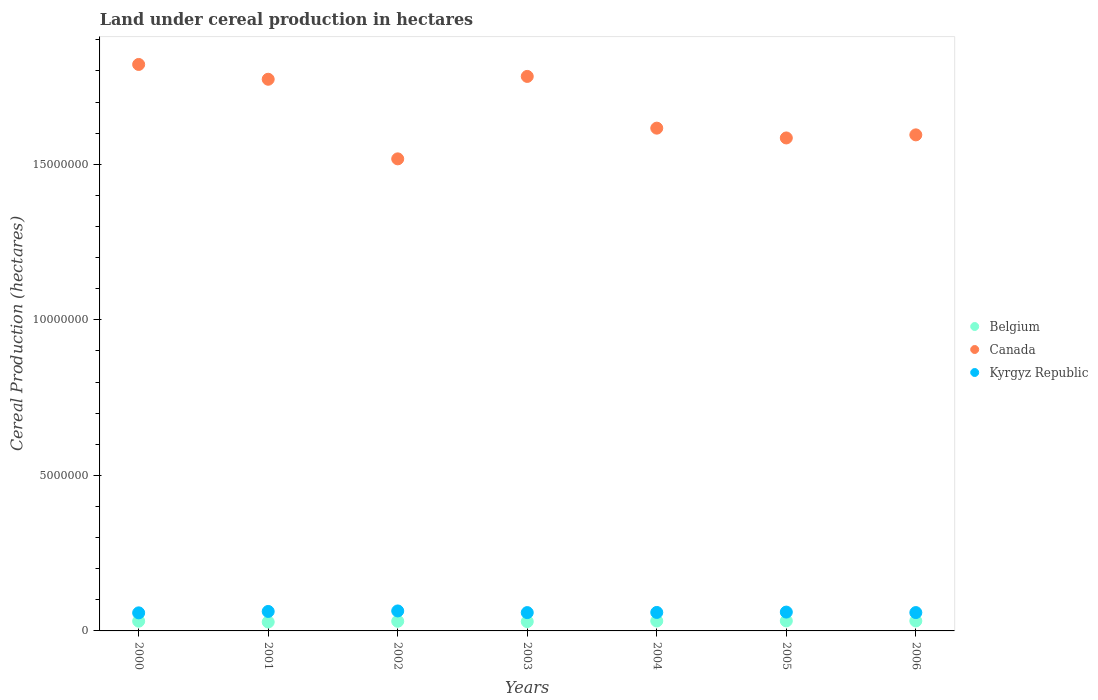Is the number of dotlines equal to the number of legend labels?
Your response must be concise. Yes. What is the land under cereal production in Kyrgyz Republic in 2002?
Offer a terse response. 6.42e+05. Across all years, what is the maximum land under cereal production in Canada?
Provide a succinct answer. 1.82e+07. Across all years, what is the minimum land under cereal production in Belgium?
Your answer should be compact. 2.87e+05. In which year was the land under cereal production in Belgium maximum?
Provide a short and direct response. 2005. What is the total land under cereal production in Canada in the graph?
Provide a short and direct response. 1.17e+08. What is the difference between the land under cereal production in Canada in 2004 and that in 2006?
Make the answer very short. 2.16e+05. What is the difference between the land under cereal production in Canada in 2004 and the land under cereal production in Kyrgyz Republic in 2003?
Keep it short and to the point. 1.56e+07. What is the average land under cereal production in Belgium per year?
Keep it short and to the point. 3.10e+05. In the year 2003, what is the difference between the land under cereal production in Canada and land under cereal production in Belgium?
Provide a short and direct response. 1.75e+07. What is the ratio of the land under cereal production in Canada in 2000 to that in 2004?
Your answer should be compact. 1.13. Is the land under cereal production in Kyrgyz Republic in 2003 less than that in 2005?
Your response must be concise. Yes. What is the difference between the highest and the second highest land under cereal production in Belgium?
Give a very brief answer. 1596. What is the difference between the highest and the lowest land under cereal production in Canada?
Your answer should be compact. 3.03e+06. Is the sum of the land under cereal production in Canada in 2000 and 2006 greater than the maximum land under cereal production in Kyrgyz Republic across all years?
Provide a short and direct response. Yes. Is it the case that in every year, the sum of the land under cereal production in Kyrgyz Republic and land under cereal production in Belgium  is greater than the land under cereal production in Canada?
Your answer should be compact. No. Is the land under cereal production in Kyrgyz Republic strictly greater than the land under cereal production in Canada over the years?
Provide a succinct answer. No. Is the land under cereal production in Belgium strictly less than the land under cereal production in Kyrgyz Republic over the years?
Keep it short and to the point. Yes. Does the graph contain any zero values?
Keep it short and to the point. No. Does the graph contain grids?
Give a very brief answer. No. Where does the legend appear in the graph?
Provide a succinct answer. Center right. How many legend labels are there?
Make the answer very short. 3. What is the title of the graph?
Provide a succinct answer. Land under cereal production in hectares. Does "San Marino" appear as one of the legend labels in the graph?
Give a very brief answer. No. What is the label or title of the Y-axis?
Your answer should be very brief. Cereal Production (hectares). What is the Cereal Production (hectares) in Belgium in 2000?
Provide a short and direct response. 3.13e+05. What is the Cereal Production (hectares) of Canada in 2000?
Give a very brief answer. 1.82e+07. What is the Cereal Production (hectares) of Kyrgyz Republic in 2000?
Your answer should be very brief. 5.81e+05. What is the Cereal Production (hectares) in Belgium in 2001?
Offer a terse response. 2.87e+05. What is the Cereal Production (hectares) in Canada in 2001?
Give a very brief answer. 1.77e+07. What is the Cereal Production (hectares) in Kyrgyz Republic in 2001?
Make the answer very short. 6.26e+05. What is the Cereal Production (hectares) of Belgium in 2002?
Provide a short and direct response. 3.10e+05. What is the Cereal Production (hectares) in Canada in 2002?
Offer a very short reply. 1.52e+07. What is the Cereal Production (hectares) of Kyrgyz Republic in 2002?
Provide a succinct answer. 6.42e+05. What is the Cereal Production (hectares) of Belgium in 2003?
Your response must be concise. 3.00e+05. What is the Cereal Production (hectares) in Canada in 2003?
Your response must be concise. 1.78e+07. What is the Cereal Production (hectares) of Kyrgyz Republic in 2003?
Keep it short and to the point. 5.89e+05. What is the Cereal Production (hectares) in Belgium in 2004?
Ensure brevity in your answer.  3.19e+05. What is the Cereal Production (hectares) in Canada in 2004?
Provide a short and direct response. 1.62e+07. What is the Cereal Production (hectares) in Kyrgyz Republic in 2004?
Your answer should be compact. 5.94e+05. What is the Cereal Production (hectares) in Belgium in 2005?
Your answer should be very brief. 3.22e+05. What is the Cereal Production (hectares) of Canada in 2005?
Your response must be concise. 1.58e+07. What is the Cereal Production (hectares) in Kyrgyz Republic in 2005?
Ensure brevity in your answer.  6.06e+05. What is the Cereal Production (hectares) in Belgium in 2006?
Your response must be concise. 3.21e+05. What is the Cereal Production (hectares) of Canada in 2006?
Keep it short and to the point. 1.59e+07. What is the Cereal Production (hectares) in Kyrgyz Republic in 2006?
Your answer should be very brief. 5.90e+05. Across all years, what is the maximum Cereal Production (hectares) of Belgium?
Your answer should be compact. 3.22e+05. Across all years, what is the maximum Cereal Production (hectares) in Canada?
Make the answer very short. 1.82e+07. Across all years, what is the maximum Cereal Production (hectares) of Kyrgyz Republic?
Give a very brief answer. 6.42e+05. Across all years, what is the minimum Cereal Production (hectares) in Belgium?
Offer a very short reply. 2.87e+05. Across all years, what is the minimum Cereal Production (hectares) of Canada?
Keep it short and to the point. 1.52e+07. Across all years, what is the minimum Cereal Production (hectares) of Kyrgyz Republic?
Ensure brevity in your answer.  5.81e+05. What is the total Cereal Production (hectares) in Belgium in the graph?
Provide a succinct answer. 2.17e+06. What is the total Cereal Production (hectares) in Canada in the graph?
Your answer should be compact. 1.17e+08. What is the total Cereal Production (hectares) of Kyrgyz Republic in the graph?
Your answer should be very brief. 4.23e+06. What is the difference between the Cereal Production (hectares) in Belgium in 2000 and that in 2001?
Give a very brief answer. 2.63e+04. What is the difference between the Cereal Production (hectares) in Canada in 2000 and that in 2001?
Offer a very short reply. 4.76e+05. What is the difference between the Cereal Production (hectares) of Kyrgyz Republic in 2000 and that in 2001?
Offer a very short reply. -4.52e+04. What is the difference between the Cereal Production (hectares) of Belgium in 2000 and that in 2002?
Your response must be concise. 2826. What is the difference between the Cereal Production (hectares) in Canada in 2000 and that in 2002?
Give a very brief answer. 3.03e+06. What is the difference between the Cereal Production (hectares) of Kyrgyz Republic in 2000 and that in 2002?
Make the answer very short. -6.17e+04. What is the difference between the Cereal Production (hectares) in Belgium in 2000 and that in 2003?
Your response must be concise. 1.31e+04. What is the difference between the Cereal Production (hectares) of Canada in 2000 and that in 2003?
Offer a terse response. 3.85e+05. What is the difference between the Cereal Production (hectares) of Kyrgyz Republic in 2000 and that in 2003?
Your answer should be compact. -8167. What is the difference between the Cereal Production (hectares) in Belgium in 2000 and that in 2004?
Keep it short and to the point. -5918. What is the difference between the Cereal Production (hectares) of Canada in 2000 and that in 2004?
Your answer should be compact. 2.05e+06. What is the difference between the Cereal Production (hectares) in Kyrgyz Republic in 2000 and that in 2004?
Your answer should be compact. -1.34e+04. What is the difference between the Cereal Production (hectares) of Belgium in 2000 and that in 2005?
Your answer should be very brief. -8866. What is the difference between the Cereal Production (hectares) in Canada in 2000 and that in 2005?
Offer a very short reply. 2.36e+06. What is the difference between the Cereal Production (hectares) in Kyrgyz Republic in 2000 and that in 2005?
Your answer should be compact. -2.48e+04. What is the difference between the Cereal Production (hectares) of Belgium in 2000 and that in 2006?
Your response must be concise. -7270. What is the difference between the Cereal Production (hectares) of Canada in 2000 and that in 2006?
Ensure brevity in your answer.  2.26e+06. What is the difference between the Cereal Production (hectares) in Kyrgyz Republic in 2000 and that in 2006?
Offer a very short reply. -8954. What is the difference between the Cereal Production (hectares) of Belgium in 2001 and that in 2002?
Provide a short and direct response. -2.35e+04. What is the difference between the Cereal Production (hectares) of Canada in 2001 and that in 2002?
Ensure brevity in your answer.  2.56e+06. What is the difference between the Cereal Production (hectares) of Kyrgyz Republic in 2001 and that in 2002?
Provide a short and direct response. -1.64e+04. What is the difference between the Cereal Production (hectares) of Belgium in 2001 and that in 2003?
Your response must be concise. -1.32e+04. What is the difference between the Cereal Production (hectares) of Canada in 2001 and that in 2003?
Your answer should be very brief. -9.12e+04. What is the difference between the Cereal Production (hectares) in Kyrgyz Republic in 2001 and that in 2003?
Give a very brief answer. 3.71e+04. What is the difference between the Cereal Production (hectares) of Belgium in 2001 and that in 2004?
Your answer should be very brief. -3.22e+04. What is the difference between the Cereal Production (hectares) in Canada in 2001 and that in 2004?
Provide a short and direct response. 1.57e+06. What is the difference between the Cereal Production (hectares) in Kyrgyz Republic in 2001 and that in 2004?
Give a very brief answer. 3.19e+04. What is the difference between the Cereal Production (hectares) in Belgium in 2001 and that in 2005?
Your response must be concise. -3.52e+04. What is the difference between the Cereal Production (hectares) in Canada in 2001 and that in 2005?
Keep it short and to the point. 1.89e+06. What is the difference between the Cereal Production (hectares) of Kyrgyz Republic in 2001 and that in 2005?
Your response must be concise. 2.04e+04. What is the difference between the Cereal Production (hectares) in Belgium in 2001 and that in 2006?
Keep it short and to the point. -3.36e+04. What is the difference between the Cereal Production (hectares) in Canada in 2001 and that in 2006?
Offer a terse response. 1.79e+06. What is the difference between the Cereal Production (hectares) of Kyrgyz Republic in 2001 and that in 2006?
Provide a short and direct response. 3.63e+04. What is the difference between the Cereal Production (hectares) in Belgium in 2002 and that in 2003?
Your answer should be compact. 1.03e+04. What is the difference between the Cereal Production (hectares) of Canada in 2002 and that in 2003?
Your response must be concise. -2.65e+06. What is the difference between the Cereal Production (hectares) of Kyrgyz Republic in 2002 and that in 2003?
Offer a terse response. 5.35e+04. What is the difference between the Cereal Production (hectares) of Belgium in 2002 and that in 2004?
Make the answer very short. -8744. What is the difference between the Cereal Production (hectares) in Canada in 2002 and that in 2004?
Your response must be concise. -9.87e+05. What is the difference between the Cereal Production (hectares) of Kyrgyz Republic in 2002 and that in 2004?
Give a very brief answer. 4.83e+04. What is the difference between the Cereal Production (hectares) of Belgium in 2002 and that in 2005?
Your response must be concise. -1.17e+04. What is the difference between the Cereal Production (hectares) in Canada in 2002 and that in 2005?
Ensure brevity in your answer.  -6.72e+05. What is the difference between the Cereal Production (hectares) of Kyrgyz Republic in 2002 and that in 2005?
Your response must be concise. 3.68e+04. What is the difference between the Cereal Production (hectares) in Belgium in 2002 and that in 2006?
Your answer should be compact. -1.01e+04. What is the difference between the Cereal Production (hectares) of Canada in 2002 and that in 2006?
Give a very brief answer. -7.71e+05. What is the difference between the Cereal Production (hectares) of Kyrgyz Republic in 2002 and that in 2006?
Give a very brief answer. 5.27e+04. What is the difference between the Cereal Production (hectares) in Belgium in 2003 and that in 2004?
Make the answer very short. -1.90e+04. What is the difference between the Cereal Production (hectares) in Canada in 2003 and that in 2004?
Give a very brief answer. 1.66e+06. What is the difference between the Cereal Production (hectares) in Kyrgyz Republic in 2003 and that in 2004?
Ensure brevity in your answer.  -5221. What is the difference between the Cereal Production (hectares) of Belgium in 2003 and that in 2005?
Your answer should be very brief. -2.20e+04. What is the difference between the Cereal Production (hectares) of Canada in 2003 and that in 2005?
Your answer should be compact. 1.98e+06. What is the difference between the Cereal Production (hectares) of Kyrgyz Republic in 2003 and that in 2005?
Offer a very short reply. -1.67e+04. What is the difference between the Cereal Production (hectares) in Belgium in 2003 and that in 2006?
Make the answer very short. -2.04e+04. What is the difference between the Cereal Production (hectares) in Canada in 2003 and that in 2006?
Give a very brief answer. 1.88e+06. What is the difference between the Cereal Production (hectares) in Kyrgyz Republic in 2003 and that in 2006?
Give a very brief answer. -787. What is the difference between the Cereal Production (hectares) in Belgium in 2004 and that in 2005?
Give a very brief answer. -2948. What is the difference between the Cereal Production (hectares) in Canada in 2004 and that in 2005?
Ensure brevity in your answer.  3.15e+05. What is the difference between the Cereal Production (hectares) in Kyrgyz Republic in 2004 and that in 2005?
Your response must be concise. -1.14e+04. What is the difference between the Cereal Production (hectares) of Belgium in 2004 and that in 2006?
Give a very brief answer. -1352. What is the difference between the Cereal Production (hectares) of Canada in 2004 and that in 2006?
Your response must be concise. 2.16e+05. What is the difference between the Cereal Production (hectares) in Kyrgyz Republic in 2004 and that in 2006?
Give a very brief answer. 4434. What is the difference between the Cereal Production (hectares) in Belgium in 2005 and that in 2006?
Ensure brevity in your answer.  1596. What is the difference between the Cereal Production (hectares) of Canada in 2005 and that in 2006?
Offer a very short reply. -9.93e+04. What is the difference between the Cereal Production (hectares) in Kyrgyz Republic in 2005 and that in 2006?
Ensure brevity in your answer.  1.59e+04. What is the difference between the Cereal Production (hectares) of Belgium in 2000 and the Cereal Production (hectares) of Canada in 2001?
Ensure brevity in your answer.  -1.74e+07. What is the difference between the Cereal Production (hectares) in Belgium in 2000 and the Cereal Production (hectares) in Kyrgyz Republic in 2001?
Offer a very short reply. -3.13e+05. What is the difference between the Cereal Production (hectares) of Canada in 2000 and the Cereal Production (hectares) of Kyrgyz Republic in 2001?
Keep it short and to the point. 1.76e+07. What is the difference between the Cereal Production (hectares) in Belgium in 2000 and the Cereal Production (hectares) in Canada in 2002?
Your answer should be compact. -1.49e+07. What is the difference between the Cereal Production (hectares) in Belgium in 2000 and the Cereal Production (hectares) in Kyrgyz Republic in 2002?
Provide a succinct answer. -3.29e+05. What is the difference between the Cereal Production (hectares) in Canada in 2000 and the Cereal Production (hectares) in Kyrgyz Republic in 2002?
Provide a succinct answer. 1.76e+07. What is the difference between the Cereal Production (hectares) in Belgium in 2000 and the Cereal Production (hectares) in Canada in 2003?
Offer a very short reply. -1.75e+07. What is the difference between the Cereal Production (hectares) of Belgium in 2000 and the Cereal Production (hectares) of Kyrgyz Republic in 2003?
Give a very brief answer. -2.76e+05. What is the difference between the Cereal Production (hectares) of Canada in 2000 and the Cereal Production (hectares) of Kyrgyz Republic in 2003?
Offer a terse response. 1.76e+07. What is the difference between the Cereal Production (hectares) of Belgium in 2000 and the Cereal Production (hectares) of Canada in 2004?
Provide a short and direct response. -1.58e+07. What is the difference between the Cereal Production (hectares) in Belgium in 2000 and the Cereal Production (hectares) in Kyrgyz Republic in 2004?
Provide a succinct answer. -2.81e+05. What is the difference between the Cereal Production (hectares) in Canada in 2000 and the Cereal Production (hectares) in Kyrgyz Republic in 2004?
Provide a succinct answer. 1.76e+07. What is the difference between the Cereal Production (hectares) in Belgium in 2000 and the Cereal Production (hectares) in Canada in 2005?
Offer a terse response. -1.55e+07. What is the difference between the Cereal Production (hectares) of Belgium in 2000 and the Cereal Production (hectares) of Kyrgyz Republic in 2005?
Give a very brief answer. -2.92e+05. What is the difference between the Cereal Production (hectares) of Canada in 2000 and the Cereal Production (hectares) of Kyrgyz Republic in 2005?
Give a very brief answer. 1.76e+07. What is the difference between the Cereal Production (hectares) in Belgium in 2000 and the Cereal Production (hectares) in Canada in 2006?
Your answer should be very brief. -1.56e+07. What is the difference between the Cereal Production (hectares) of Belgium in 2000 and the Cereal Production (hectares) of Kyrgyz Republic in 2006?
Offer a terse response. -2.76e+05. What is the difference between the Cereal Production (hectares) in Canada in 2000 and the Cereal Production (hectares) in Kyrgyz Republic in 2006?
Make the answer very short. 1.76e+07. What is the difference between the Cereal Production (hectares) of Belgium in 2001 and the Cereal Production (hectares) of Canada in 2002?
Offer a terse response. -1.49e+07. What is the difference between the Cereal Production (hectares) of Belgium in 2001 and the Cereal Production (hectares) of Kyrgyz Republic in 2002?
Ensure brevity in your answer.  -3.55e+05. What is the difference between the Cereal Production (hectares) in Canada in 2001 and the Cereal Production (hectares) in Kyrgyz Republic in 2002?
Your answer should be compact. 1.71e+07. What is the difference between the Cereal Production (hectares) of Belgium in 2001 and the Cereal Production (hectares) of Canada in 2003?
Ensure brevity in your answer.  -1.75e+07. What is the difference between the Cereal Production (hectares) of Belgium in 2001 and the Cereal Production (hectares) of Kyrgyz Republic in 2003?
Ensure brevity in your answer.  -3.02e+05. What is the difference between the Cereal Production (hectares) in Canada in 2001 and the Cereal Production (hectares) in Kyrgyz Republic in 2003?
Ensure brevity in your answer.  1.71e+07. What is the difference between the Cereal Production (hectares) in Belgium in 2001 and the Cereal Production (hectares) in Canada in 2004?
Keep it short and to the point. -1.59e+07. What is the difference between the Cereal Production (hectares) in Belgium in 2001 and the Cereal Production (hectares) in Kyrgyz Republic in 2004?
Your response must be concise. -3.07e+05. What is the difference between the Cereal Production (hectares) in Canada in 2001 and the Cereal Production (hectares) in Kyrgyz Republic in 2004?
Keep it short and to the point. 1.71e+07. What is the difference between the Cereal Production (hectares) of Belgium in 2001 and the Cereal Production (hectares) of Canada in 2005?
Provide a short and direct response. -1.56e+07. What is the difference between the Cereal Production (hectares) of Belgium in 2001 and the Cereal Production (hectares) of Kyrgyz Republic in 2005?
Keep it short and to the point. -3.19e+05. What is the difference between the Cereal Production (hectares) in Canada in 2001 and the Cereal Production (hectares) in Kyrgyz Republic in 2005?
Offer a terse response. 1.71e+07. What is the difference between the Cereal Production (hectares) in Belgium in 2001 and the Cereal Production (hectares) in Canada in 2006?
Keep it short and to the point. -1.57e+07. What is the difference between the Cereal Production (hectares) of Belgium in 2001 and the Cereal Production (hectares) of Kyrgyz Republic in 2006?
Ensure brevity in your answer.  -3.03e+05. What is the difference between the Cereal Production (hectares) of Canada in 2001 and the Cereal Production (hectares) of Kyrgyz Republic in 2006?
Make the answer very short. 1.71e+07. What is the difference between the Cereal Production (hectares) in Belgium in 2002 and the Cereal Production (hectares) in Canada in 2003?
Your answer should be very brief. -1.75e+07. What is the difference between the Cereal Production (hectares) in Belgium in 2002 and the Cereal Production (hectares) in Kyrgyz Republic in 2003?
Keep it short and to the point. -2.78e+05. What is the difference between the Cereal Production (hectares) of Canada in 2002 and the Cereal Production (hectares) of Kyrgyz Republic in 2003?
Provide a succinct answer. 1.46e+07. What is the difference between the Cereal Production (hectares) in Belgium in 2002 and the Cereal Production (hectares) in Canada in 2004?
Make the answer very short. -1.59e+07. What is the difference between the Cereal Production (hectares) of Belgium in 2002 and the Cereal Production (hectares) of Kyrgyz Republic in 2004?
Your response must be concise. -2.84e+05. What is the difference between the Cereal Production (hectares) of Canada in 2002 and the Cereal Production (hectares) of Kyrgyz Republic in 2004?
Offer a terse response. 1.46e+07. What is the difference between the Cereal Production (hectares) in Belgium in 2002 and the Cereal Production (hectares) in Canada in 2005?
Keep it short and to the point. -1.55e+07. What is the difference between the Cereal Production (hectares) in Belgium in 2002 and the Cereal Production (hectares) in Kyrgyz Republic in 2005?
Your answer should be compact. -2.95e+05. What is the difference between the Cereal Production (hectares) in Canada in 2002 and the Cereal Production (hectares) in Kyrgyz Republic in 2005?
Provide a succinct answer. 1.46e+07. What is the difference between the Cereal Production (hectares) in Belgium in 2002 and the Cereal Production (hectares) in Canada in 2006?
Your answer should be compact. -1.56e+07. What is the difference between the Cereal Production (hectares) of Belgium in 2002 and the Cereal Production (hectares) of Kyrgyz Republic in 2006?
Offer a terse response. -2.79e+05. What is the difference between the Cereal Production (hectares) of Canada in 2002 and the Cereal Production (hectares) of Kyrgyz Republic in 2006?
Make the answer very short. 1.46e+07. What is the difference between the Cereal Production (hectares) of Belgium in 2003 and the Cereal Production (hectares) of Canada in 2004?
Your answer should be compact. -1.59e+07. What is the difference between the Cereal Production (hectares) of Belgium in 2003 and the Cereal Production (hectares) of Kyrgyz Republic in 2004?
Provide a short and direct response. -2.94e+05. What is the difference between the Cereal Production (hectares) of Canada in 2003 and the Cereal Production (hectares) of Kyrgyz Republic in 2004?
Give a very brief answer. 1.72e+07. What is the difference between the Cereal Production (hectares) of Belgium in 2003 and the Cereal Production (hectares) of Canada in 2005?
Offer a terse response. -1.55e+07. What is the difference between the Cereal Production (hectares) in Belgium in 2003 and the Cereal Production (hectares) in Kyrgyz Republic in 2005?
Your answer should be compact. -3.05e+05. What is the difference between the Cereal Production (hectares) of Canada in 2003 and the Cereal Production (hectares) of Kyrgyz Republic in 2005?
Provide a short and direct response. 1.72e+07. What is the difference between the Cereal Production (hectares) of Belgium in 2003 and the Cereal Production (hectares) of Canada in 2006?
Provide a succinct answer. -1.56e+07. What is the difference between the Cereal Production (hectares) of Belgium in 2003 and the Cereal Production (hectares) of Kyrgyz Republic in 2006?
Your answer should be very brief. -2.89e+05. What is the difference between the Cereal Production (hectares) of Canada in 2003 and the Cereal Production (hectares) of Kyrgyz Republic in 2006?
Offer a terse response. 1.72e+07. What is the difference between the Cereal Production (hectares) of Belgium in 2004 and the Cereal Production (hectares) of Canada in 2005?
Make the answer very short. -1.55e+07. What is the difference between the Cereal Production (hectares) in Belgium in 2004 and the Cereal Production (hectares) in Kyrgyz Republic in 2005?
Your answer should be compact. -2.86e+05. What is the difference between the Cereal Production (hectares) of Canada in 2004 and the Cereal Production (hectares) of Kyrgyz Republic in 2005?
Make the answer very short. 1.56e+07. What is the difference between the Cereal Production (hectares) in Belgium in 2004 and the Cereal Production (hectares) in Canada in 2006?
Offer a very short reply. -1.56e+07. What is the difference between the Cereal Production (hectares) of Belgium in 2004 and the Cereal Production (hectares) of Kyrgyz Republic in 2006?
Offer a terse response. -2.70e+05. What is the difference between the Cereal Production (hectares) in Canada in 2004 and the Cereal Production (hectares) in Kyrgyz Republic in 2006?
Provide a short and direct response. 1.56e+07. What is the difference between the Cereal Production (hectares) of Belgium in 2005 and the Cereal Production (hectares) of Canada in 2006?
Make the answer very short. -1.56e+07. What is the difference between the Cereal Production (hectares) in Belgium in 2005 and the Cereal Production (hectares) in Kyrgyz Republic in 2006?
Keep it short and to the point. -2.67e+05. What is the difference between the Cereal Production (hectares) in Canada in 2005 and the Cereal Production (hectares) in Kyrgyz Republic in 2006?
Keep it short and to the point. 1.53e+07. What is the average Cereal Production (hectares) in Belgium per year?
Your answer should be compact. 3.10e+05. What is the average Cereal Production (hectares) in Canada per year?
Your answer should be very brief. 1.67e+07. What is the average Cereal Production (hectares) of Kyrgyz Republic per year?
Offer a terse response. 6.04e+05. In the year 2000, what is the difference between the Cereal Production (hectares) of Belgium and Cereal Production (hectares) of Canada?
Provide a short and direct response. -1.79e+07. In the year 2000, what is the difference between the Cereal Production (hectares) of Belgium and Cereal Production (hectares) of Kyrgyz Republic?
Your answer should be very brief. -2.67e+05. In the year 2000, what is the difference between the Cereal Production (hectares) in Canada and Cereal Production (hectares) in Kyrgyz Republic?
Keep it short and to the point. 1.76e+07. In the year 2001, what is the difference between the Cereal Production (hectares) in Belgium and Cereal Production (hectares) in Canada?
Keep it short and to the point. -1.74e+07. In the year 2001, what is the difference between the Cereal Production (hectares) of Belgium and Cereal Production (hectares) of Kyrgyz Republic?
Offer a terse response. -3.39e+05. In the year 2001, what is the difference between the Cereal Production (hectares) in Canada and Cereal Production (hectares) in Kyrgyz Republic?
Ensure brevity in your answer.  1.71e+07. In the year 2002, what is the difference between the Cereal Production (hectares) in Belgium and Cereal Production (hectares) in Canada?
Ensure brevity in your answer.  -1.49e+07. In the year 2002, what is the difference between the Cereal Production (hectares) in Belgium and Cereal Production (hectares) in Kyrgyz Republic?
Your answer should be very brief. -3.32e+05. In the year 2002, what is the difference between the Cereal Production (hectares) of Canada and Cereal Production (hectares) of Kyrgyz Republic?
Give a very brief answer. 1.45e+07. In the year 2003, what is the difference between the Cereal Production (hectares) in Belgium and Cereal Production (hectares) in Canada?
Provide a short and direct response. -1.75e+07. In the year 2003, what is the difference between the Cereal Production (hectares) of Belgium and Cereal Production (hectares) of Kyrgyz Republic?
Keep it short and to the point. -2.89e+05. In the year 2003, what is the difference between the Cereal Production (hectares) of Canada and Cereal Production (hectares) of Kyrgyz Republic?
Offer a very short reply. 1.72e+07. In the year 2004, what is the difference between the Cereal Production (hectares) of Belgium and Cereal Production (hectares) of Canada?
Provide a succinct answer. -1.58e+07. In the year 2004, what is the difference between the Cereal Production (hectares) of Belgium and Cereal Production (hectares) of Kyrgyz Republic?
Your answer should be very brief. -2.75e+05. In the year 2004, what is the difference between the Cereal Production (hectares) of Canada and Cereal Production (hectares) of Kyrgyz Republic?
Offer a very short reply. 1.56e+07. In the year 2005, what is the difference between the Cereal Production (hectares) in Belgium and Cereal Production (hectares) in Canada?
Offer a very short reply. -1.55e+07. In the year 2005, what is the difference between the Cereal Production (hectares) of Belgium and Cereal Production (hectares) of Kyrgyz Republic?
Give a very brief answer. -2.83e+05. In the year 2005, what is the difference between the Cereal Production (hectares) in Canada and Cereal Production (hectares) in Kyrgyz Republic?
Offer a terse response. 1.52e+07. In the year 2006, what is the difference between the Cereal Production (hectares) of Belgium and Cereal Production (hectares) of Canada?
Provide a short and direct response. -1.56e+07. In the year 2006, what is the difference between the Cereal Production (hectares) in Belgium and Cereal Production (hectares) in Kyrgyz Republic?
Your response must be concise. -2.69e+05. In the year 2006, what is the difference between the Cereal Production (hectares) in Canada and Cereal Production (hectares) in Kyrgyz Republic?
Offer a very short reply. 1.54e+07. What is the ratio of the Cereal Production (hectares) in Belgium in 2000 to that in 2001?
Make the answer very short. 1.09. What is the ratio of the Cereal Production (hectares) of Canada in 2000 to that in 2001?
Your response must be concise. 1.03. What is the ratio of the Cereal Production (hectares) of Kyrgyz Republic in 2000 to that in 2001?
Ensure brevity in your answer.  0.93. What is the ratio of the Cereal Production (hectares) in Belgium in 2000 to that in 2002?
Your answer should be very brief. 1.01. What is the ratio of the Cereal Production (hectares) of Canada in 2000 to that in 2002?
Keep it short and to the point. 1.2. What is the ratio of the Cereal Production (hectares) of Kyrgyz Republic in 2000 to that in 2002?
Provide a short and direct response. 0.9. What is the ratio of the Cereal Production (hectares) of Belgium in 2000 to that in 2003?
Your response must be concise. 1.04. What is the ratio of the Cereal Production (hectares) in Canada in 2000 to that in 2003?
Your answer should be compact. 1.02. What is the ratio of the Cereal Production (hectares) in Kyrgyz Republic in 2000 to that in 2003?
Your response must be concise. 0.99. What is the ratio of the Cereal Production (hectares) of Belgium in 2000 to that in 2004?
Offer a very short reply. 0.98. What is the ratio of the Cereal Production (hectares) of Canada in 2000 to that in 2004?
Provide a short and direct response. 1.13. What is the ratio of the Cereal Production (hectares) of Kyrgyz Republic in 2000 to that in 2004?
Keep it short and to the point. 0.98. What is the ratio of the Cereal Production (hectares) of Belgium in 2000 to that in 2005?
Offer a very short reply. 0.97. What is the ratio of the Cereal Production (hectares) of Canada in 2000 to that in 2005?
Offer a terse response. 1.15. What is the ratio of the Cereal Production (hectares) in Belgium in 2000 to that in 2006?
Your answer should be compact. 0.98. What is the ratio of the Cereal Production (hectares) of Canada in 2000 to that in 2006?
Offer a very short reply. 1.14. What is the ratio of the Cereal Production (hectares) in Belgium in 2001 to that in 2002?
Provide a succinct answer. 0.92. What is the ratio of the Cereal Production (hectares) of Canada in 2001 to that in 2002?
Provide a short and direct response. 1.17. What is the ratio of the Cereal Production (hectares) of Kyrgyz Republic in 2001 to that in 2002?
Offer a terse response. 0.97. What is the ratio of the Cereal Production (hectares) in Belgium in 2001 to that in 2003?
Keep it short and to the point. 0.96. What is the ratio of the Cereal Production (hectares) of Canada in 2001 to that in 2003?
Ensure brevity in your answer.  0.99. What is the ratio of the Cereal Production (hectares) in Kyrgyz Republic in 2001 to that in 2003?
Your answer should be compact. 1.06. What is the ratio of the Cereal Production (hectares) in Belgium in 2001 to that in 2004?
Offer a very short reply. 0.9. What is the ratio of the Cereal Production (hectares) of Canada in 2001 to that in 2004?
Your answer should be compact. 1.1. What is the ratio of the Cereal Production (hectares) in Kyrgyz Republic in 2001 to that in 2004?
Give a very brief answer. 1.05. What is the ratio of the Cereal Production (hectares) of Belgium in 2001 to that in 2005?
Make the answer very short. 0.89. What is the ratio of the Cereal Production (hectares) of Canada in 2001 to that in 2005?
Provide a succinct answer. 1.12. What is the ratio of the Cereal Production (hectares) of Kyrgyz Republic in 2001 to that in 2005?
Your answer should be very brief. 1.03. What is the ratio of the Cereal Production (hectares) of Belgium in 2001 to that in 2006?
Ensure brevity in your answer.  0.9. What is the ratio of the Cereal Production (hectares) of Canada in 2001 to that in 2006?
Ensure brevity in your answer.  1.11. What is the ratio of the Cereal Production (hectares) of Kyrgyz Republic in 2001 to that in 2006?
Your answer should be compact. 1.06. What is the ratio of the Cereal Production (hectares) in Belgium in 2002 to that in 2003?
Your answer should be compact. 1.03. What is the ratio of the Cereal Production (hectares) of Canada in 2002 to that in 2003?
Keep it short and to the point. 0.85. What is the ratio of the Cereal Production (hectares) of Kyrgyz Republic in 2002 to that in 2003?
Give a very brief answer. 1.09. What is the ratio of the Cereal Production (hectares) in Belgium in 2002 to that in 2004?
Give a very brief answer. 0.97. What is the ratio of the Cereal Production (hectares) in Canada in 2002 to that in 2004?
Offer a very short reply. 0.94. What is the ratio of the Cereal Production (hectares) of Kyrgyz Republic in 2002 to that in 2004?
Keep it short and to the point. 1.08. What is the ratio of the Cereal Production (hectares) in Belgium in 2002 to that in 2005?
Provide a short and direct response. 0.96. What is the ratio of the Cereal Production (hectares) in Canada in 2002 to that in 2005?
Make the answer very short. 0.96. What is the ratio of the Cereal Production (hectares) in Kyrgyz Republic in 2002 to that in 2005?
Provide a succinct answer. 1.06. What is the ratio of the Cereal Production (hectares) in Belgium in 2002 to that in 2006?
Keep it short and to the point. 0.97. What is the ratio of the Cereal Production (hectares) of Canada in 2002 to that in 2006?
Your answer should be very brief. 0.95. What is the ratio of the Cereal Production (hectares) of Kyrgyz Republic in 2002 to that in 2006?
Make the answer very short. 1.09. What is the ratio of the Cereal Production (hectares) of Belgium in 2003 to that in 2004?
Your answer should be compact. 0.94. What is the ratio of the Cereal Production (hectares) of Canada in 2003 to that in 2004?
Provide a short and direct response. 1.1. What is the ratio of the Cereal Production (hectares) of Kyrgyz Republic in 2003 to that in 2004?
Offer a terse response. 0.99. What is the ratio of the Cereal Production (hectares) in Belgium in 2003 to that in 2005?
Ensure brevity in your answer.  0.93. What is the ratio of the Cereal Production (hectares) of Canada in 2003 to that in 2005?
Your answer should be very brief. 1.12. What is the ratio of the Cereal Production (hectares) of Kyrgyz Republic in 2003 to that in 2005?
Your answer should be very brief. 0.97. What is the ratio of the Cereal Production (hectares) in Belgium in 2003 to that in 2006?
Give a very brief answer. 0.94. What is the ratio of the Cereal Production (hectares) in Canada in 2003 to that in 2006?
Keep it short and to the point. 1.12. What is the ratio of the Cereal Production (hectares) in Kyrgyz Republic in 2003 to that in 2006?
Ensure brevity in your answer.  1. What is the ratio of the Cereal Production (hectares) of Canada in 2004 to that in 2005?
Provide a short and direct response. 1.02. What is the ratio of the Cereal Production (hectares) in Kyrgyz Republic in 2004 to that in 2005?
Provide a short and direct response. 0.98. What is the ratio of the Cereal Production (hectares) in Belgium in 2004 to that in 2006?
Offer a very short reply. 1. What is the ratio of the Cereal Production (hectares) of Canada in 2004 to that in 2006?
Provide a short and direct response. 1.01. What is the ratio of the Cereal Production (hectares) in Kyrgyz Republic in 2004 to that in 2006?
Your answer should be very brief. 1.01. What is the ratio of the Cereal Production (hectares) in Belgium in 2005 to that in 2006?
Ensure brevity in your answer.  1. What is the ratio of the Cereal Production (hectares) in Canada in 2005 to that in 2006?
Provide a succinct answer. 0.99. What is the ratio of the Cereal Production (hectares) of Kyrgyz Republic in 2005 to that in 2006?
Offer a very short reply. 1.03. What is the difference between the highest and the second highest Cereal Production (hectares) of Belgium?
Provide a short and direct response. 1596. What is the difference between the highest and the second highest Cereal Production (hectares) of Canada?
Provide a short and direct response. 3.85e+05. What is the difference between the highest and the second highest Cereal Production (hectares) in Kyrgyz Republic?
Make the answer very short. 1.64e+04. What is the difference between the highest and the lowest Cereal Production (hectares) of Belgium?
Make the answer very short. 3.52e+04. What is the difference between the highest and the lowest Cereal Production (hectares) in Canada?
Your response must be concise. 3.03e+06. What is the difference between the highest and the lowest Cereal Production (hectares) in Kyrgyz Republic?
Your answer should be very brief. 6.17e+04. 